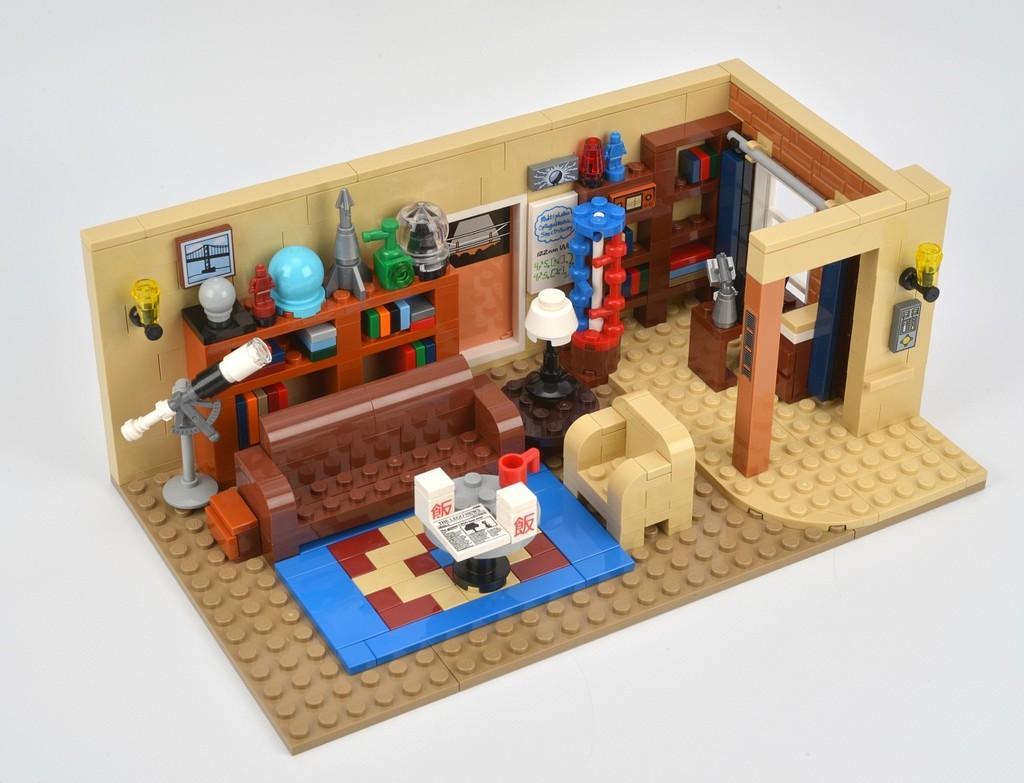How would you summarize this image in a sentence or two? In this picture we can see a miniature and it is created by building blocks. 